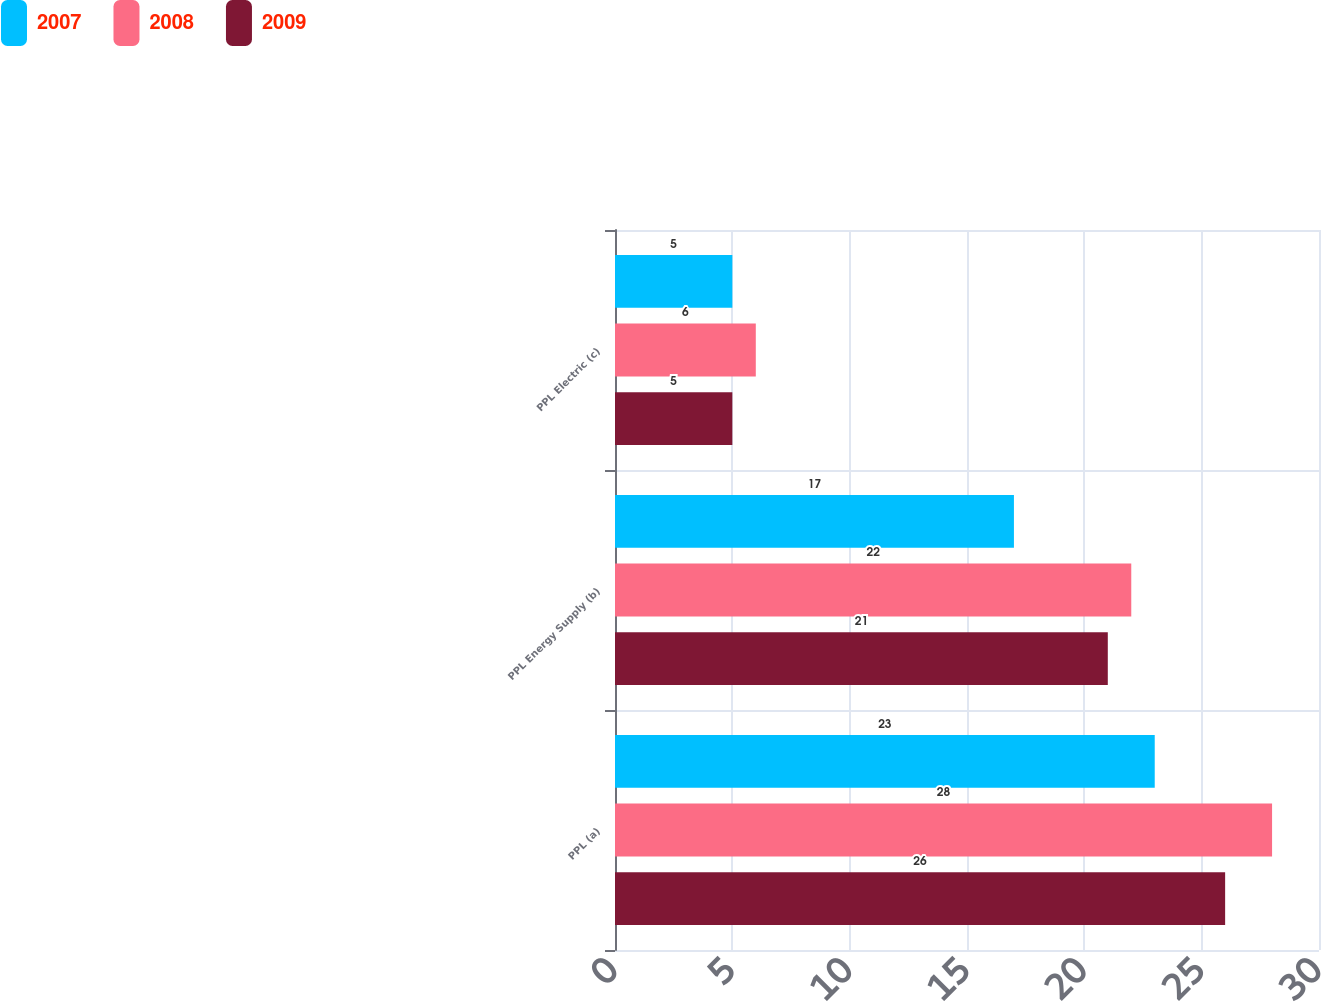<chart> <loc_0><loc_0><loc_500><loc_500><stacked_bar_chart><ecel><fcel>PPL (a)<fcel>PPL Energy Supply (b)<fcel>PPL Electric (c)<nl><fcel>2007<fcel>23<fcel>17<fcel>5<nl><fcel>2008<fcel>28<fcel>22<fcel>6<nl><fcel>2009<fcel>26<fcel>21<fcel>5<nl></chart> 